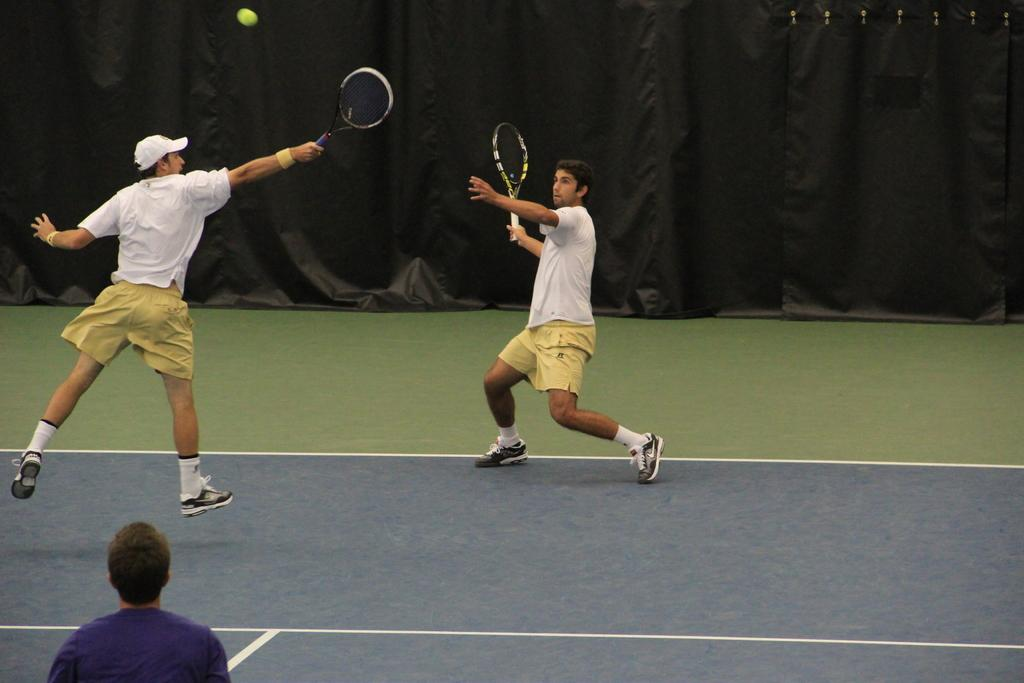How many people are in the image? There are two persons in the image. What are the persons doing in the image? The persons are playing tennis. What is the position of the persons in the image? The persons are standing. What can be seen in the background of the image? There is a black cloth in the background of the image. Who is the creator of the tennis racket used by one of the persons in the image? The provided facts do not mention the brand or creator of the tennis racket, so it cannot be determined from the image. 